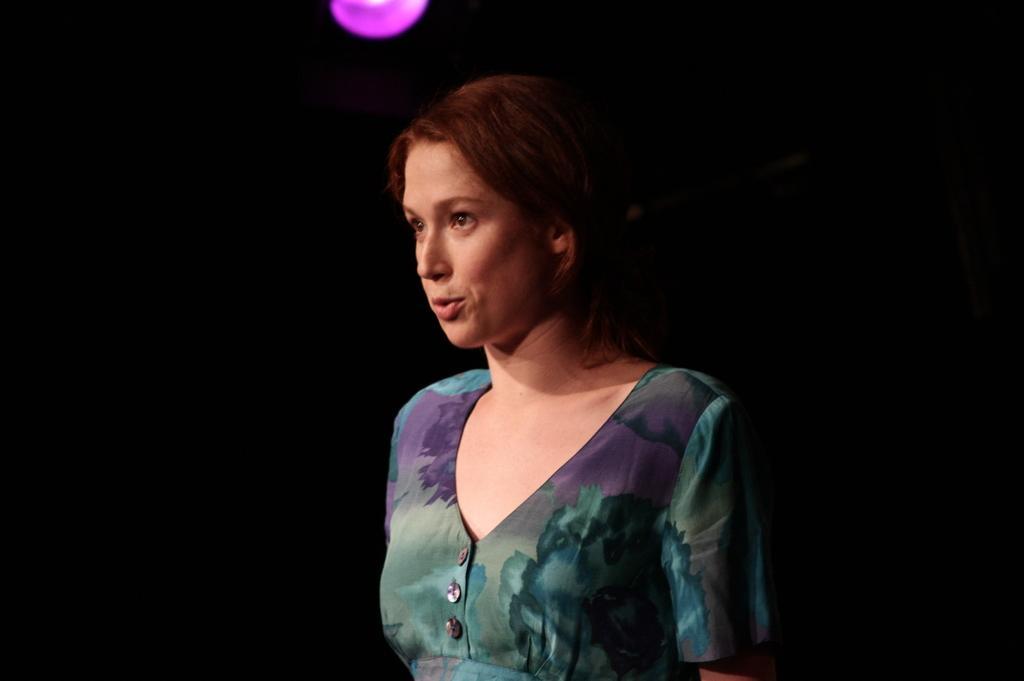In one or two sentences, can you explain what this image depicts? In this image there is a woman with floral dress. At the back there is a black background. At the top there is light. 